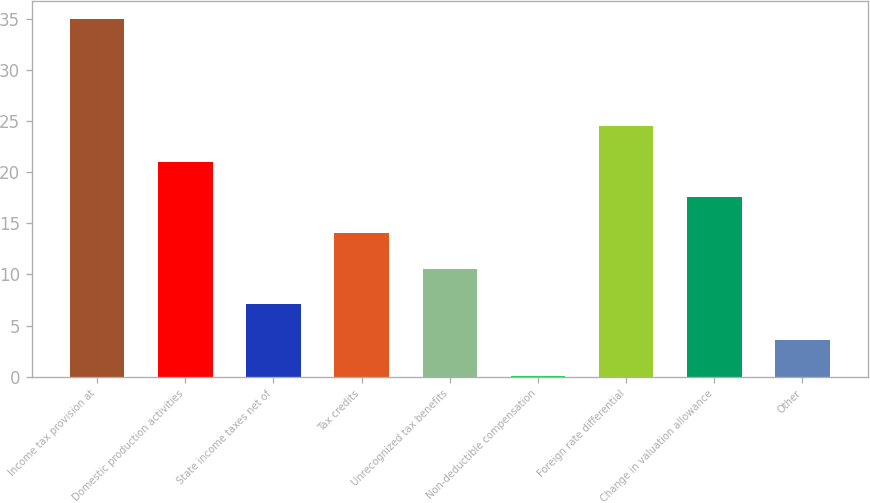<chart> <loc_0><loc_0><loc_500><loc_500><bar_chart><fcel>Income tax provision at<fcel>Domestic production activities<fcel>State income taxes net of<fcel>Tax credits<fcel>Unrecognized tax benefits<fcel>Non-deductible compensation<fcel>Foreign rate differential<fcel>Change in valuation allowance<fcel>Other<nl><fcel>35<fcel>21.04<fcel>7.08<fcel>14.06<fcel>10.57<fcel>0.1<fcel>24.53<fcel>17.55<fcel>3.59<nl></chart> 